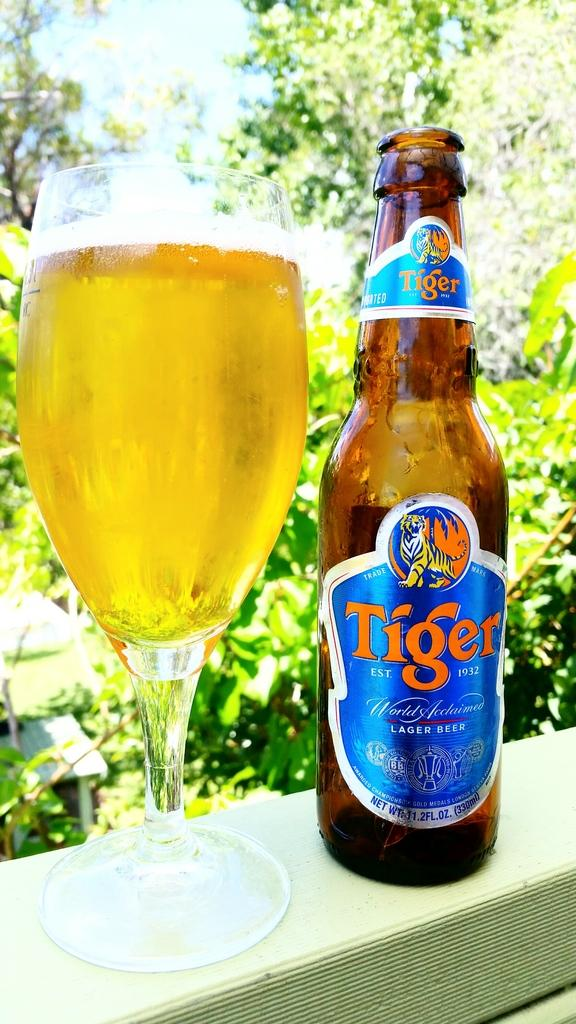<image>
Give a short and clear explanation of the subsequent image. A bottle of tiger beer sits next to a glass of beer. 